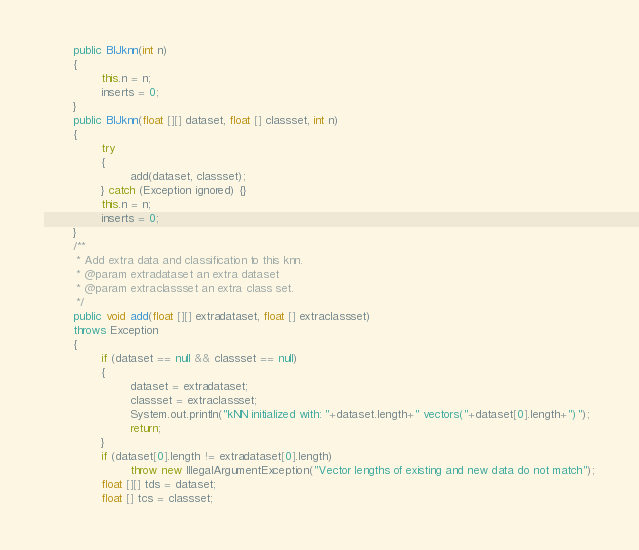Convert code to text. <code><loc_0><loc_0><loc_500><loc_500><_Java_>
        public BIJknn(int n)
        {
                this.n = n;
                inserts = 0;
        }
        public BIJknn(float [][] dataset, float [] classset, int n)
        {
                try
                {
                        add(dataset, classset);
                } catch (Exception ignored) {}
                this.n = n;
                inserts = 0;
        }
        /**
         * Add extra data and classification to this knn.
         * @param extradataset an extra dataset
         * @param extraclassset an extra class set.
         */
        public void add(float [][] extradataset, float [] extraclassset)
        throws Exception
        {
                if (dataset == null && classset == null)
                {
                        dataset = extradataset;
                        classset = extraclassset;
                        System.out.println("kNN initialized with: "+dataset.length+" vectors("+dataset[0].length+")");
                        return;
                }
                if (dataset[0].length != extradataset[0].length)
                        throw new IllegalArgumentException("Vector lengths of existing and new data do not match");
                float [][] tds = dataset;
                float [] tcs = classset;</code> 